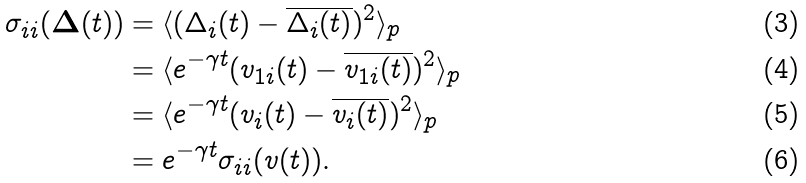<formula> <loc_0><loc_0><loc_500><loc_500>\sigma _ { i i } ( \mathbf \Delta ( t ) ) & = \langle ( \Delta _ { i } ( t ) - \overline { \Delta _ { i } ( t ) } ) ^ { 2 } \rangle _ { p } \\ & = \langle e ^ { - \gamma t } ( v _ { 1 i } ( t ) - \overline { v _ { 1 i } ( t ) } ) ^ { 2 } \rangle _ { p } \\ & = \langle e ^ { - \gamma t } ( v _ { i } ( t ) - \overline { v _ { i } ( t ) } ) ^ { 2 } \rangle _ { p } \\ & = e ^ { - \gamma t } \sigma _ { i i } ( v ( t ) ) .</formula> 